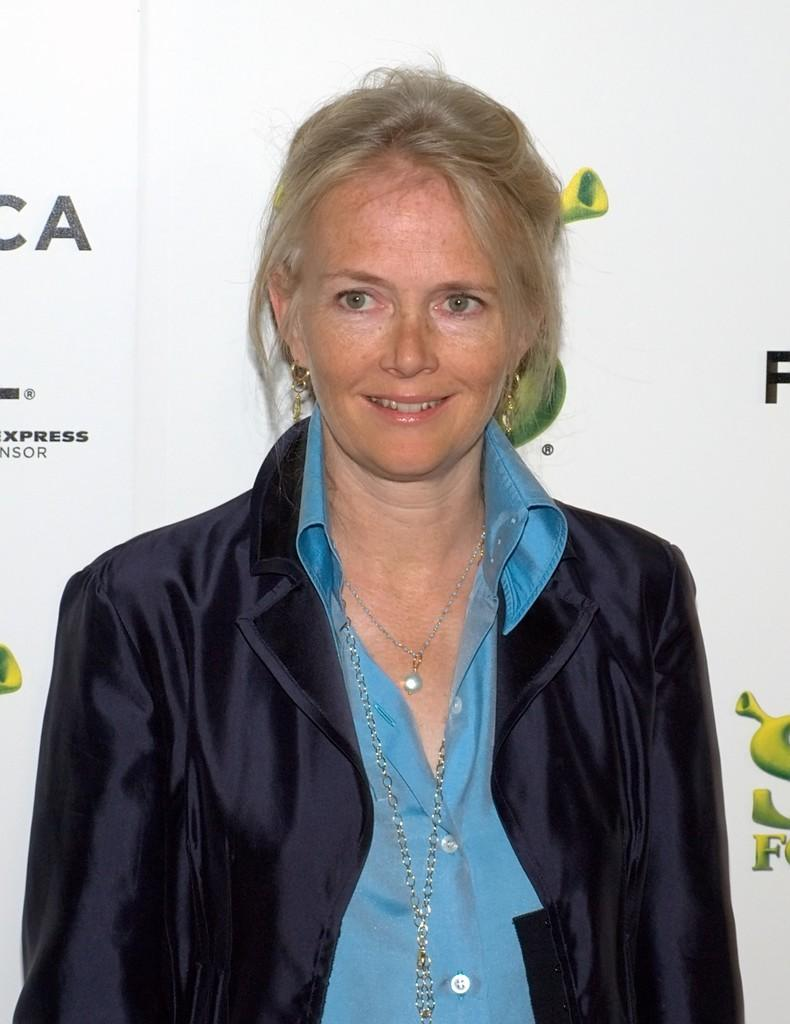Who is present in the image? There is a lady in the image. What can be seen in the background of the image? There is a poster with text in the background of the image. What advice does the lady give to the truck driver in the image? There is no truck driver or any indication of advice-giving in the image. 